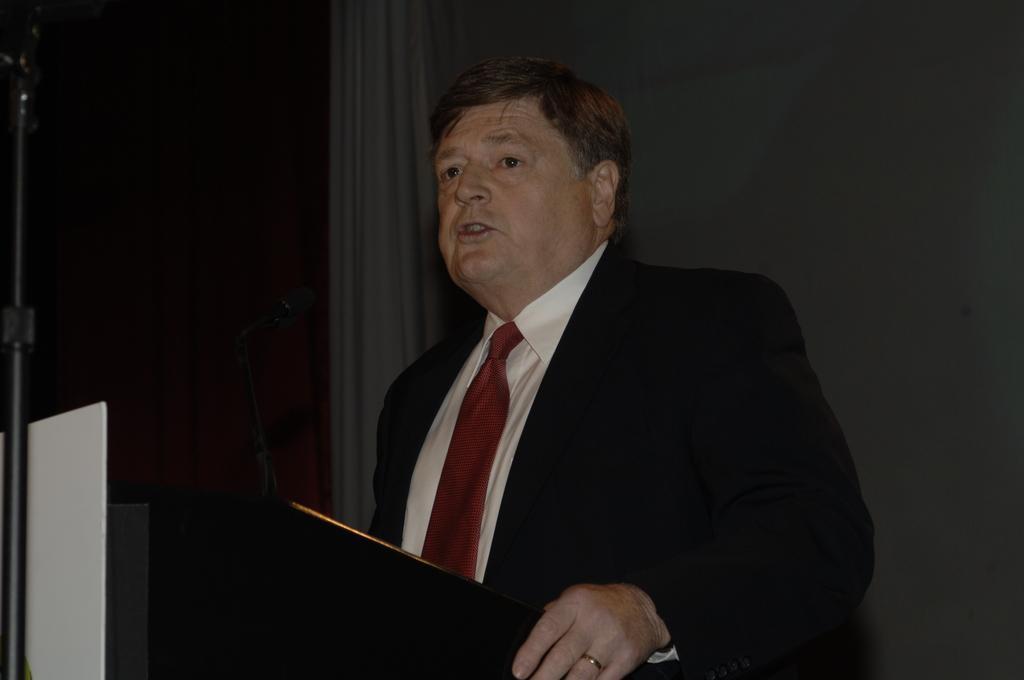Please provide a concise description of this image. In this picture there is a man standing, in front of him we can see a microphone on the podium. We can see board on stand. In the background of the image it is dark and we can see curtain. 